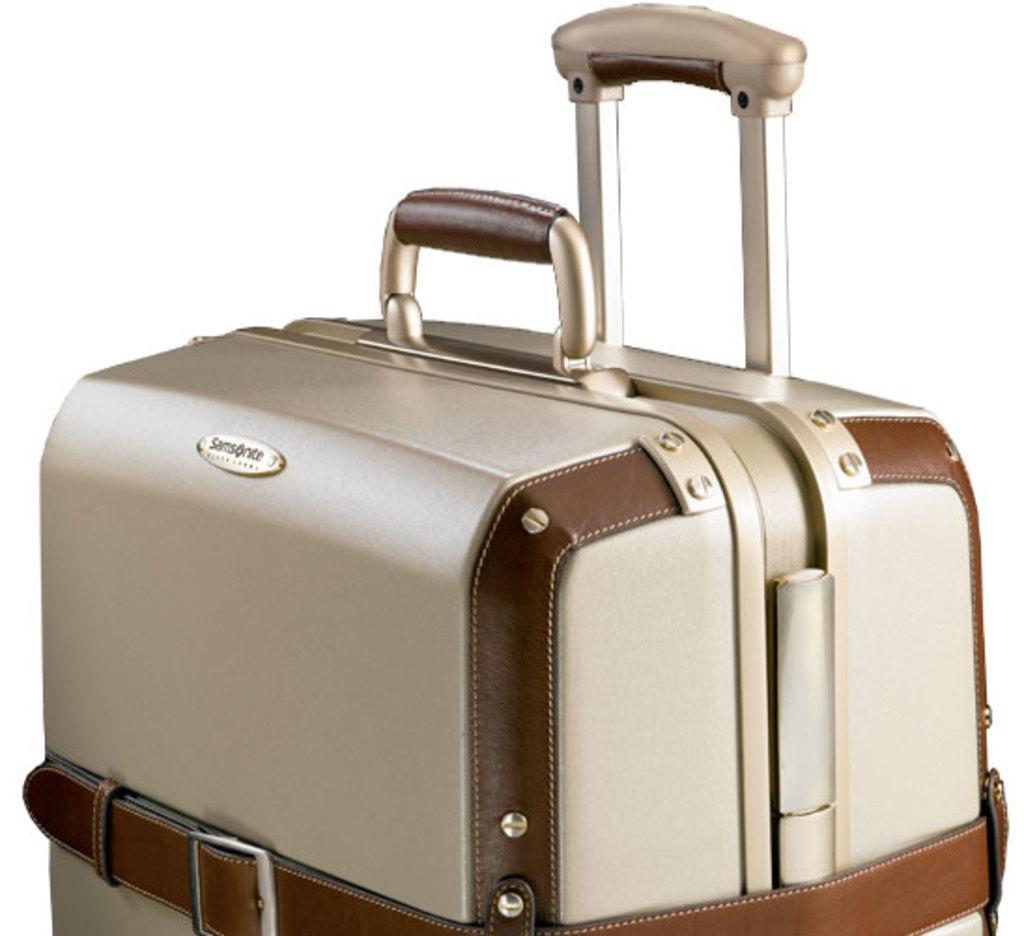In one or two sentences, can you explain what this image depicts? In the image it is a a screenshot of a picture,it is a luggage bag it is of cream and brown color there are two handles for this luggage,there is also a belt in front of the luggage. 